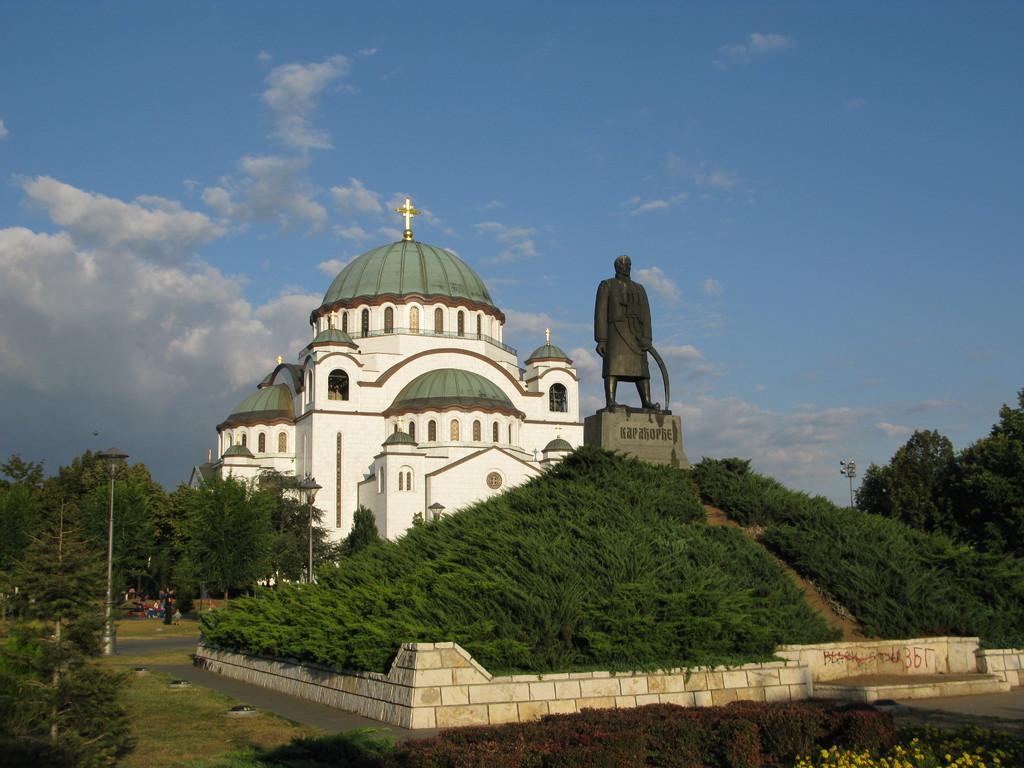How would you summarize this image in a sentence or two? In this image there is a church in the middle. In front of the church there is a statue. At the top there is the sky. At the bottom there are trees and light poles. 